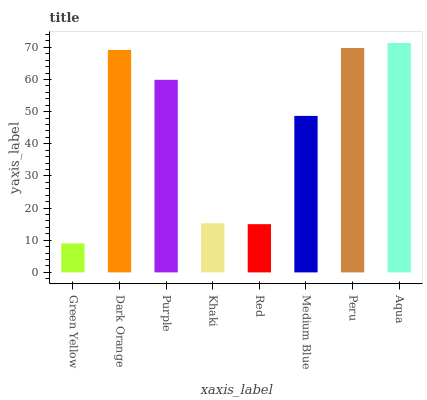Is Dark Orange the minimum?
Answer yes or no. No. Is Dark Orange the maximum?
Answer yes or no. No. Is Dark Orange greater than Green Yellow?
Answer yes or no. Yes. Is Green Yellow less than Dark Orange?
Answer yes or no. Yes. Is Green Yellow greater than Dark Orange?
Answer yes or no. No. Is Dark Orange less than Green Yellow?
Answer yes or no. No. Is Purple the high median?
Answer yes or no. Yes. Is Medium Blue the low median?
Answer yes or no. Yes. Is Medium Blue the high median?
Answer yes or no. No. Is Red the low median?
Answer yes or no. No. 